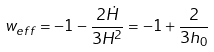Convert formula to latex. <formula><loc_0><loc_0><loc_500><loc_500>w _ { e f f } = - 1 - \frac { 2 \dot { H } } { 3 H ^ { 2 } } = - 1 + \frac { 2 } { 3 h _ { 0 } }</formula> 